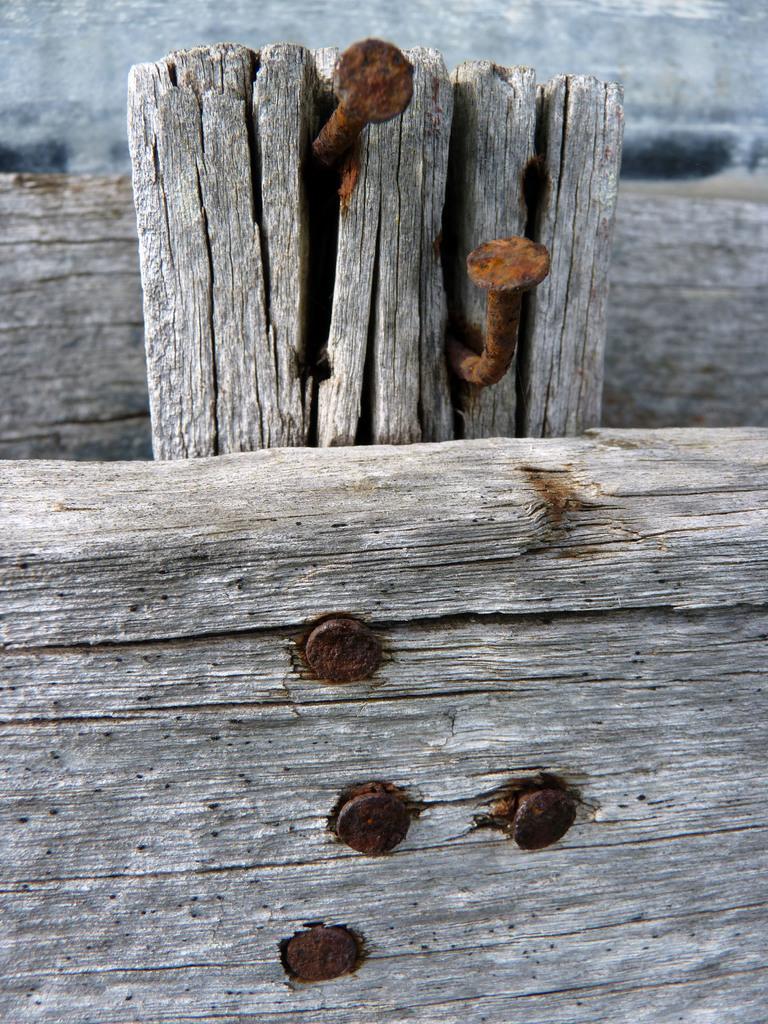Please provide a concise description of this image. In this picture there is a bamboo in the center and at the bottom side of the image on which there are nails. 